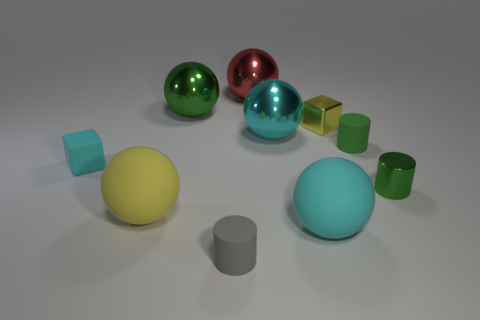What material is the cube that is left of the big metal sphere that is in front of the yellow shiny thing made of?
Give a very brief answer. Rubber. What number of other objects are the same material as the big red ball?
Make the answer very short. 4. Does the small gray matte thing have the same shape as the tiny cyan object?
Provide a short and direct response. No. There is a gray object left of the tiny metallic cylinder; what is its size?
Your answer should be very brief. Small. There is a metal cube; does it have the same size as the matte sphere that is on the right side of the green metal sphere?
Your response must be concise. No. Is the number of metal spheres that are right of the metallic cylinder less than the number of small brown things?
Your response must be concise. No. There is another green object that is the same shape as the small green metal thing; what is its material?
Provide a short and direct response. Rubber. The tiny rubber thing that is both behind the yellow sphere and on the left side of the green rubber cylinder has what shape?
Keep it short and to the point. Cube. What shape is the large green object that is the same material as the red sphere?
Your response must be concise. Sphere. What is the yellow object left of the yellow cube made of?
Provide a short and direct response. Rubber. 